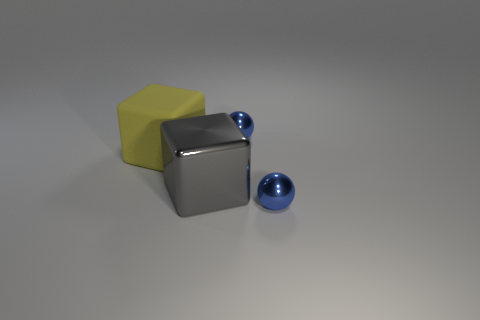There is a metallic thing that is behind the large block to the left of the big gray object that is to the right of the big rubber block; what is its shape? The metallic item behind the large block, situated to the left of the big gray cube and to the right of the large rubber block, is spherical in shape. Specifically, it appears as a polished metal ball, reflecting the ambient light. 